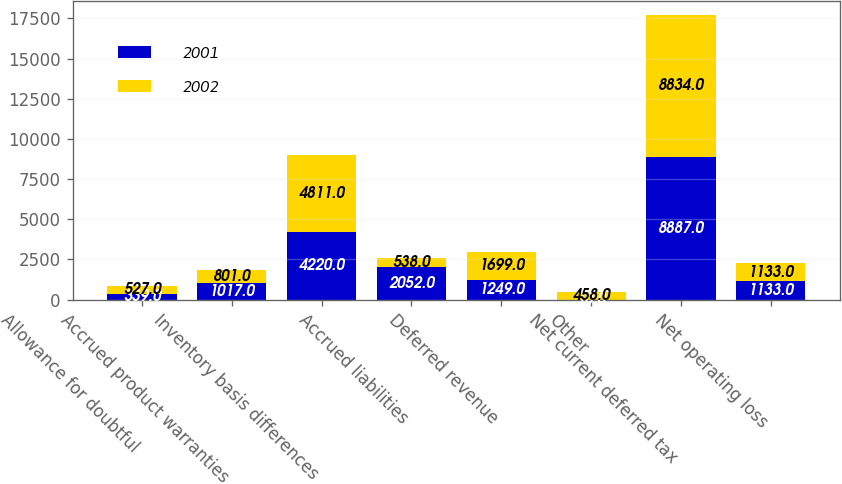<chart> <loc_0><loc_0><loc_500><loc_500><stacked_bar_chart><ecel><fcel>Allowance for doubtful<fcel>Accrued product warranties<fcel>Inventory basis differences<fcel>Accrued liabilities<fcel>Deferred revenue<fcel>Other<fcel>Net current deferred tax<fcel>Net operating loss<nl><fcel>2001<fcel>339<fcel>1017<fcel>4220<fcel>2052<fcel>1249<fcel>10<fcel>8887<fcel>1133<nl><fcel>2002<fcel>527<fcel>801<fcel>4811<fcel>538<fcel>1699<fcel>458<fcel>8834<fcel>1133<nl></chart> 